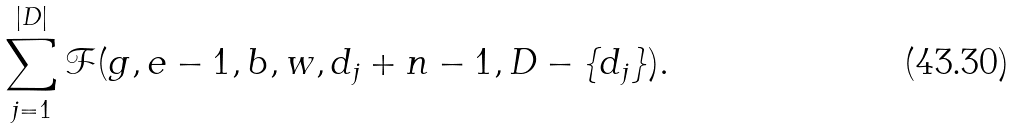Convert formula to latex. <formula><loc_0><loc_0><loc_500><loc_500>\sum _ { j = 1 } ^ { | D | } \mathcal { F } ( g , e - 1 , b , w , d _ { j } + n - 1 , D - \{ d _ { j } \} ) .</formula> 